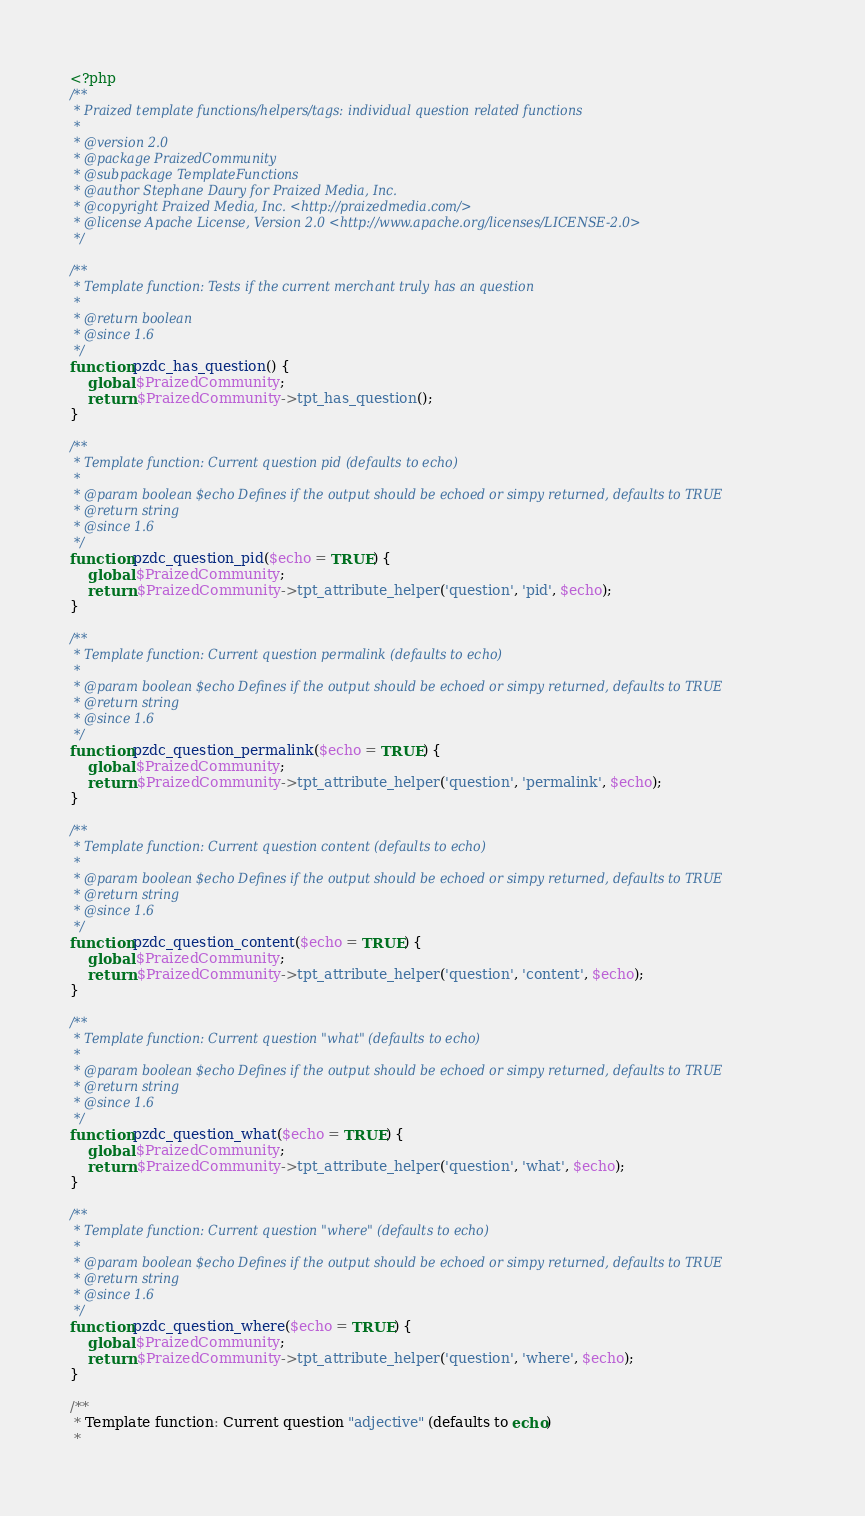Convert code to text. <code><loc_0><loc_0><loc_500><loc_500><_PHP_><?php
/**
 * Praized template functions/helpers/tags: individual question related functions
 * 
 * @version 2.0
 * @package PraizedCommunity
 * @subpackage TemplateFunctions
 * @author Stephane Daury for Praized Media, Inc.
 * @copyright Praized Media, Inc. <http://praizedmedia.com/>
 * @license Apache License, Version 2.0 <http://www.apache.org/licenses/LICENSE-2.0>
 */

/**
 * Template function: Tests if the current merchant truly has an question
 *
 * @return boolean
 * @since 1.6
 */
function pzdc_has_question() {
    global $PraizedCommunity;
    return $PraizedCommunity->tpt_has_question();
}

/**
 * Template function: Current question pid (defaults to echo)
 *
 * @param boolean $echo Defines if the output should be echoed or simpy returned, defaults to TRUE
 * @return string
 * @since 1.6
 */
function pzdc_question_pid($echo = TRUE) {
    global $PraizedCommunity;
    return $PraizedCommunity->tpt_attribute_helper('question', 'pid', $echo);
}

/**
 * Template function: Current question permalink (defaults to echo)
 *
 * @param boolean $echo Defines if the output should be echoed or simpy returned, defaults to TRUE
 * @return string
 * @since 1.6
 */
function pzdc_question_permalink($echo = TRUE) {
    global $PraizedCommunity;
    return $PraizedCommunity->tpt_attribute_helper('question', 'permalink', $echo);
}

/**
 * Template function: Current question content (defaults to echo)
 *
 * @param boolean $echo Defines if the output should be echoed or simpy returned, defaults to TRUE
 * @return string
 * @since 1.6
 */
function pzdc_question_content($echo = TRUE) {
    global $PraizedCommunity;
    return $PraizedCommunity->tpt_attribute_helper('question', 'content', $echo);
}

/**
 * Template function: Current question "what" (defaults to echo)
 *
 * @param boolean $echo Defines if the output should be echoed or simpy returned, defaults to TRUE
 * @return string
 * @since 1.6
 */
function pzdc_question_what($echo = TRUE) {
    global $PraizedCommunity;
    return $PraizedCommunity->tpt_attribute_helper('question', 'what', $echo);
}

/**
 * Template function: Current question "where" (defaults to echo)
 *
 * @param boolean $echo Defines if the output should be echoed or simpy returned, defaults to TRUE
 * @return string
 * @since 1.6
 */
function pzdc_question_where($echo = TRUE) {
    global $PraizedCommunity;
    return $PraizedCommunity->tpt_attribute_helper('question', 'where', $echo);
}

/**
 * Template function: Current question "adjective" (defaults to echo)
 *</code> 